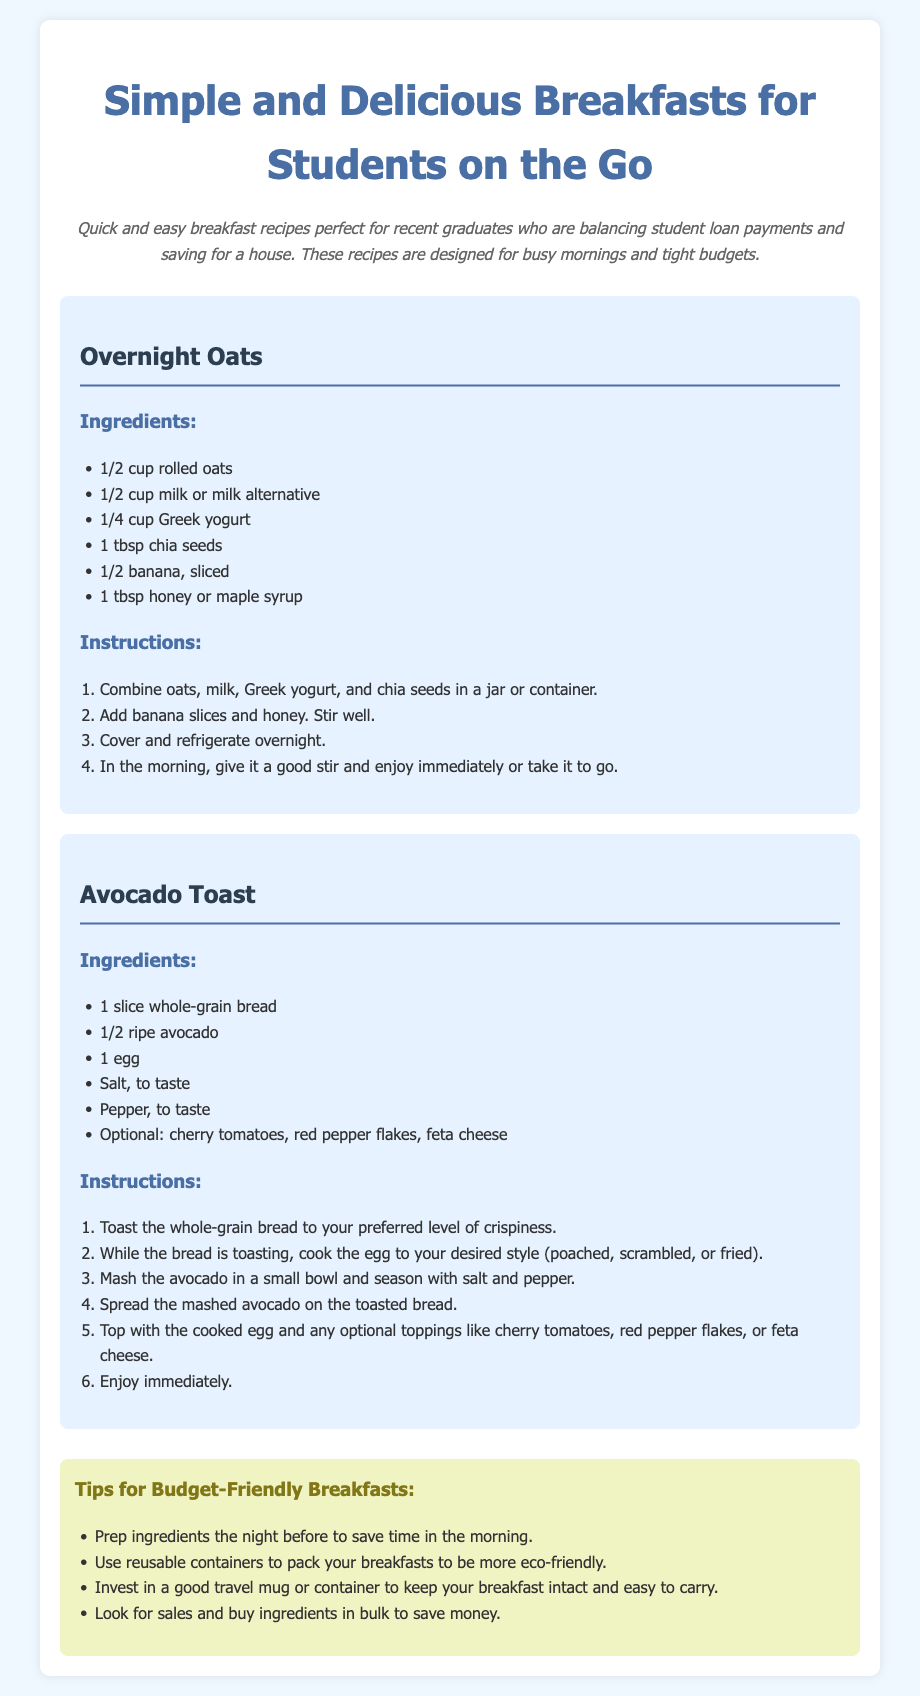what are the ingredients for Overnight Oats? The ingredients list for Overnight Oats includes rolled oats, milk or milk alternative, Greek yogurt, chia seeds, banana, and honey or maple syrup.
Answer: 1/2 cup rolled oats, 1/2 cup milk or milk alternative, 1/4 cup Greek yogurt, 1 tbsp chia seeds, 1/2 banana, 1 tbsp honey or maple syrup how many steps are there in the Avocado Toast instructions? The instructions for Avocado Toast have a total of 6 steps.
Answer: 6 what ingredient is optional in the Avocado Toast recipe? The optional ingredients for the Avocado Toast recipe include cherry tomatoes, red pepper flakes, and feta cheese.
Answer: cherry tomatoes, red pepper flakes, feta cheese what is the target audience of this recipe card? The recipe card is designed for recent graduates who are balancing student loan payments and saving for a house.
Answer: recent graduates what should you do to prepare your breakfast the night before? To prepare for breakfast the night before, you can prep ingredients to save time in the morning.
Answer: prep ingredients what color is the background of the recipe card? The background color of the recipe card is light blue (#f0f8ff).
Answer: light blue what is the first ingredient listed for Overnight Oats? The first ingredient listed for Overnight Oats is rolled oats.
Answer: rolled oats what type of bread is used in the Avocado Toast recipe? The type of bread used in the Avocado Toast recipe is whole-grain bread.
Answer: whole-grain bread 